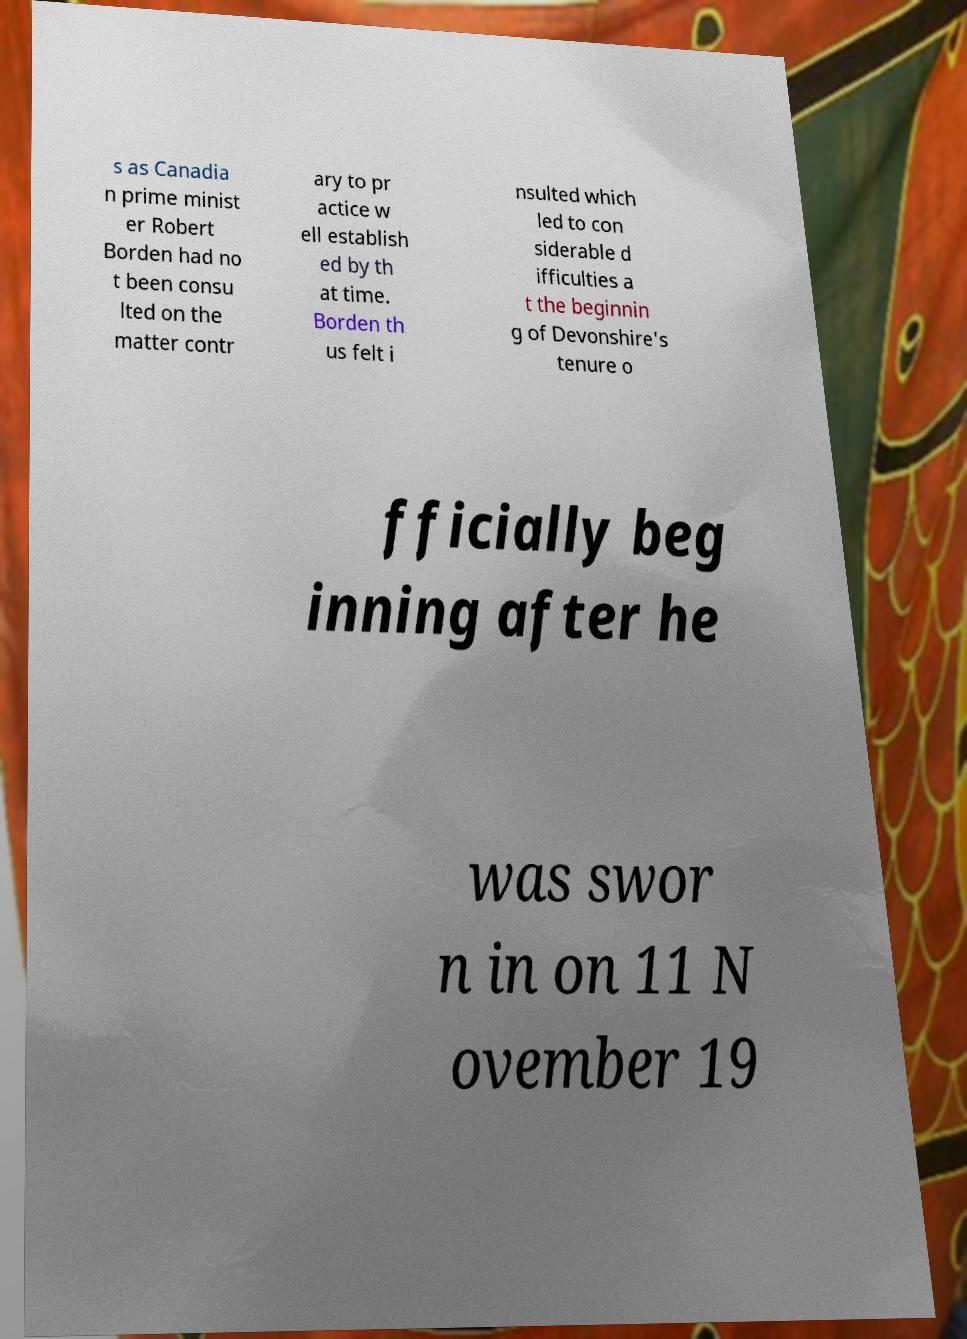Could you assist in decoding the text presented in this image and type it out clearly? s as Canadia n prime minist er Robert Borden had no t been consu lted on the matter contr ary to pr actice w ell establish ed by th at time. Borden th us felt i nsulted which led to con siderable d ifficulties a t the beginnin g of Devonshire's tenure o fficially beg inning after he was swor n in on 11 N ovember 19 